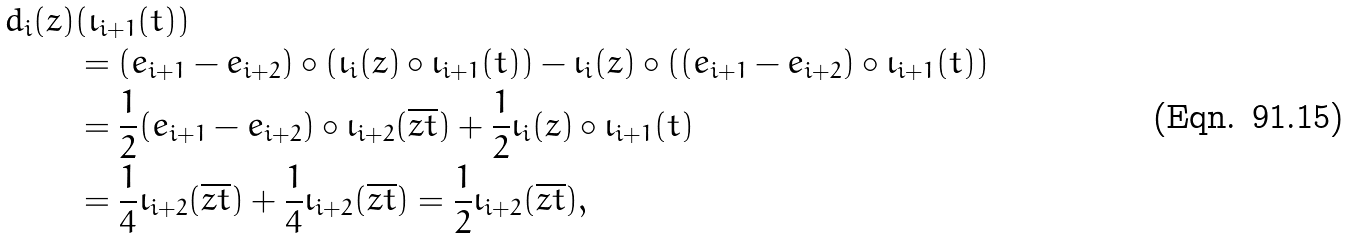Convert formula to latex. <formula><loc_0><loc_0><loc_500><loc_500>d _ { i } ( z ) & ( \iota _ { i + 1 } ( t ) ) \\ & = ( e _ { i + 1 } - e _ { i + 2 } ) \circ ( \iota _ { i } ( z ) \circ \iota _ { i + 1 } ( t ) ) - \iota _ { i } ( z ) \circ ( ( e _ { i + 1 } - e _ { i + 2 } ) \circ \iota _ { i + 1 } ( t ) ) \\ & = \frac { 1 } { 2 } ( e _ { i + 1 } - e _ { i + 2 } ) \circ \iota _ { i + 2 } ( \overline { z t } ) + \frac { 1 } { 2 } \iota _ { i } ( z ) \circ \iota _ { i + 1 } ( t ) \\ & = \frac { 1 } { 4 } \iota _ { i + 2 } ( \overline { z t } ) + \frac { 1 } { 4 } \iota _ { i + 2 } ( \overline { z t } ) = \frac { 1 } { 2 } \iota _ { i + 2 } ( \overline { z t } ) ,</formula> 